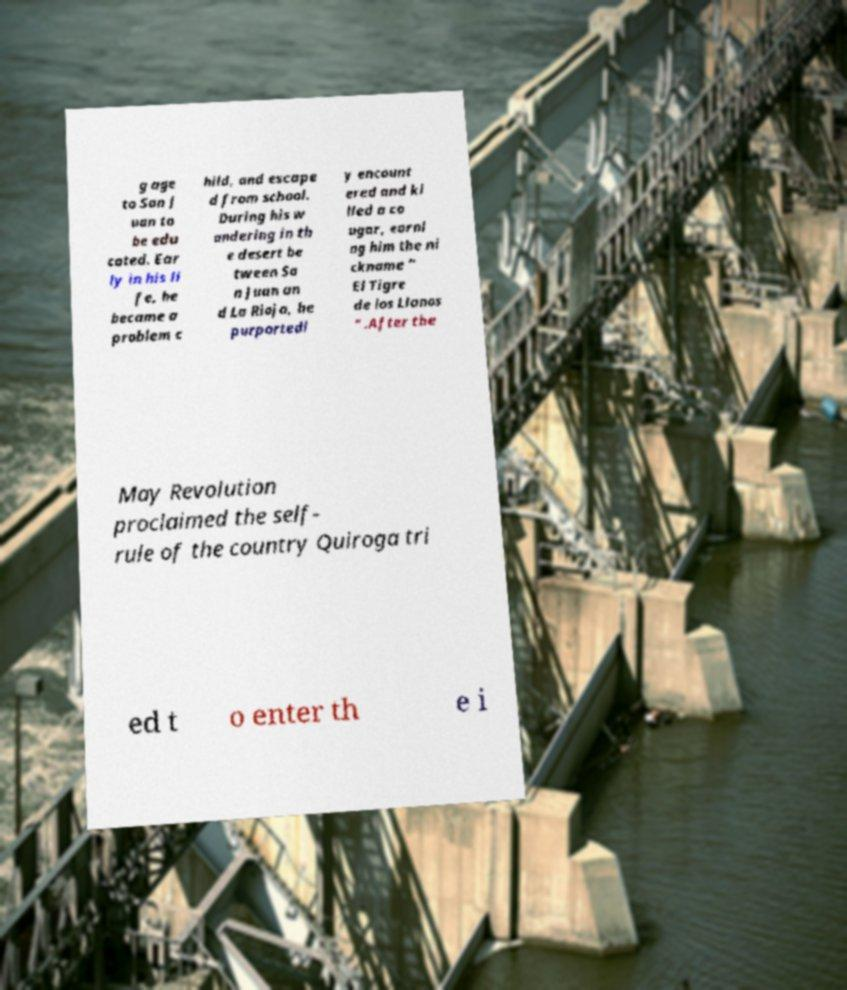Can you read and provide the text displayed in the image?This photo seems to have some interesting text. Can you extract and type it out for me? g age to San J uan to be edu cated. Ear ly in his li fe, he became a problem c hild, and escape d from school. During his w andering in th e desert be tween Sa n Juan an d La Rioja, he purportedl y encount ered and ki lled a co ugar, earni ng him the ni ckname " El Tigre de los Llanos " .After the May Revolution proclaimed the self- rule of the country Quiroga tri ed t o enter th e i 